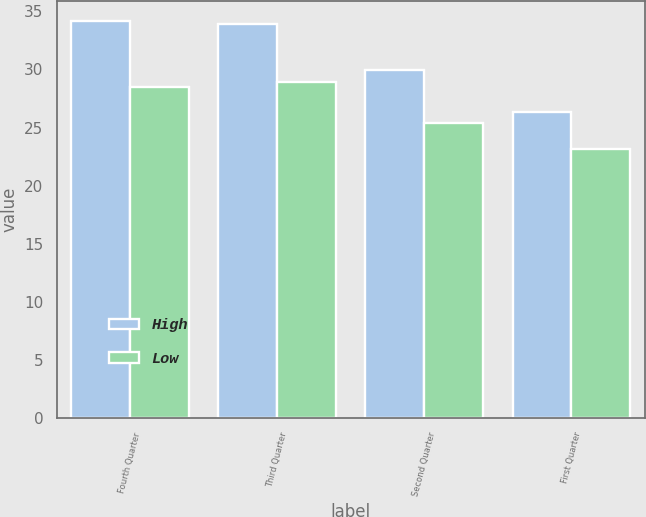<chart> <loc_0><loc_0><loc_500><loc_500><stacked_bar_chart><ecel><fcel>Fourth Quarter<fcel>Third Quarter<fcel>Second Quarter<fcel>First Quarter<nl><fcel>High<fcel>34.17<fcel>33.94<fcel>29.97<fcel>26.3<nl><fcel>Low<fcel>28.45<fcel>28.96<fcel>25.35<fcel>23.19<nl></chart> 